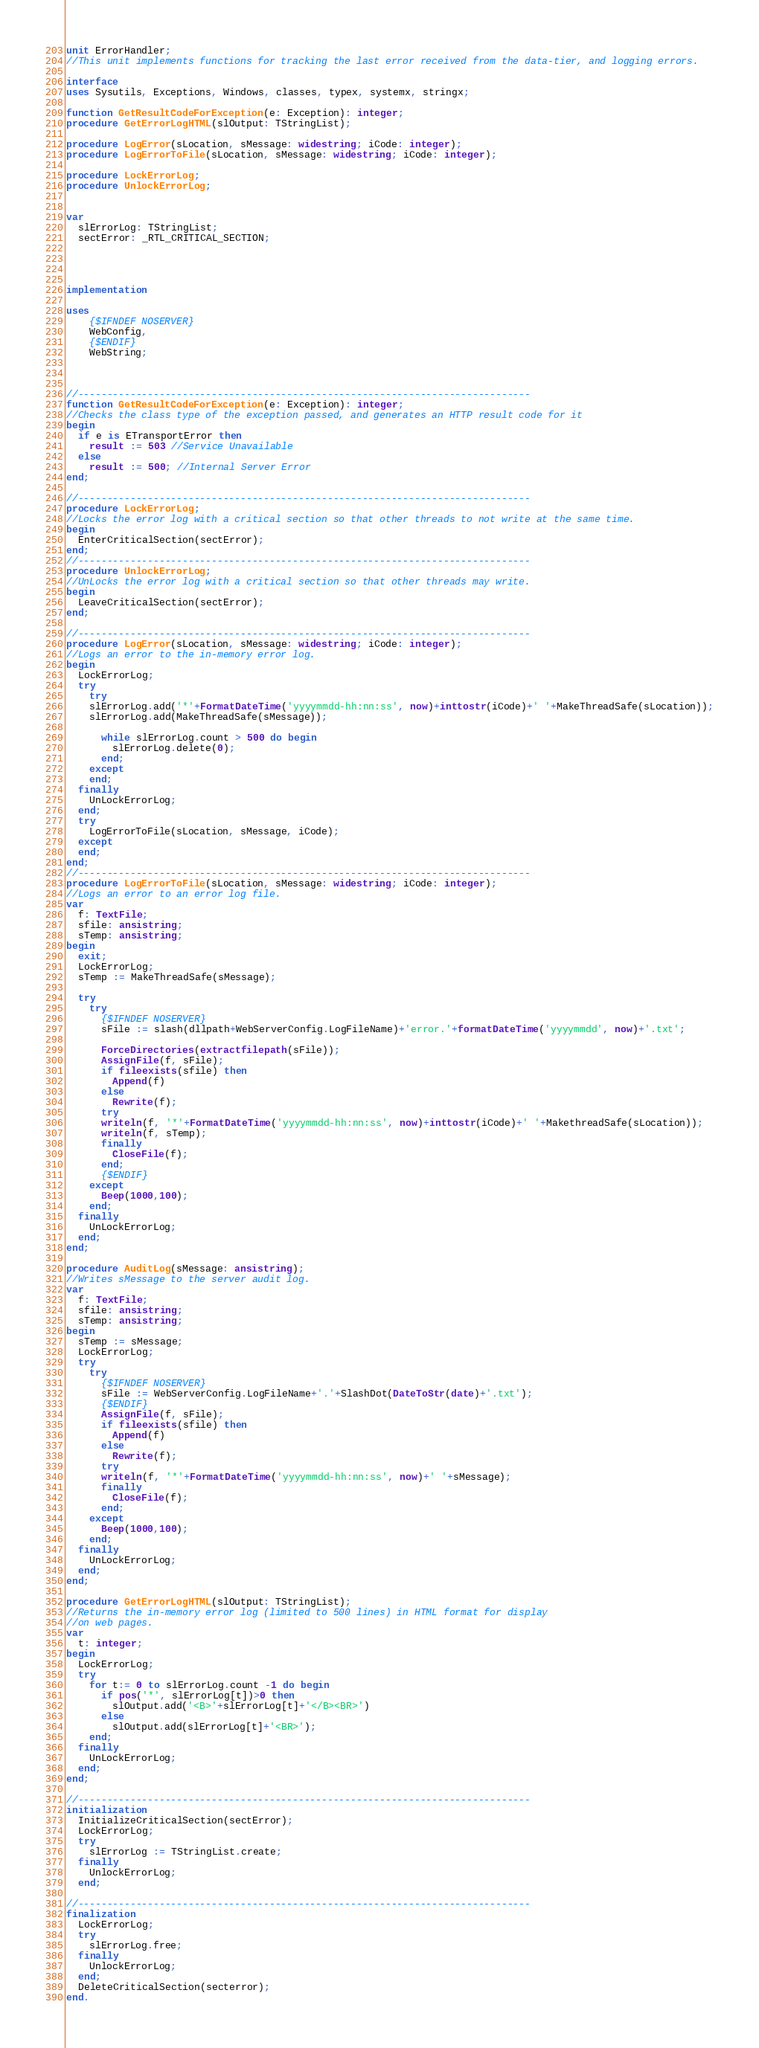Convert code to text. <code><loc_0><loc_0><loc_500><loc_500><_Pascal_>unit ErrorHandler;
//This unit implements functions for tracking the last error received from the data-tier, and logging errors.

interface
uses Sysutils, Exceptions, Windows, classes, typex, systemx, stringx;

function GetResultCodeForException(e: Exception): integer;
procedure GetErrorLogHTML(slOutput: TStringList);

procedure LogError(sLocation, sMessage: widestring; iCode: integer);
procedure LogErrorToFile(sLocation, sMessage: widestring; iCode: integer);

procedure LockErrorLog;
procedure UnlockErrorLog;


var
  slErrorLog: TStringList;
  sectError: _RTL_CRITICAL_SECTION;




implementation

uses
    {$IFNDEF NOSERVER}
    WebConfig,
    {$ENDIF}
    WebString;



//------------------------------------------------------------------------------
function GetResultCodeForException(e: Exception): integer;
//Checks the class type of the exception passed, and generates an HTTP result code for it
begin
  if e is ETransportError then
    result := 503 //Service Unavailable
  else
    result := 500; //Internal Server Error
end;

//------------------------------------------------------------------------------
procedure LockErrorLog;
//Locks the error log with a critical section so that other threads to not write at the same time.
begin
  EnterCriticalSection(sectError);
end;
//------------------------------------------------------------------------------
procedure UnlockErrorLog;
//UnLocks the error log with a critical section so that other threads may write.
begin
  LeaveCriticalSection(sectError);
end;

//------------------------------------------------------------------------------
procedure LogError(sLocation, sMessage: widestring; iCode: integer);
//Logs an error to the in-memory error log.
begin
  LockErrorLog;
  try
    try
    slErrorLog.add('*'+FormatDateTime('yyyymmdd-hh:nn:ss', now)+inttostr(iCode)+' '+MakeThreadSafe(sLocation));
    slErrorLog.add(MakeThreadSafe(sMessage));

      while slErrorLog.count > 500 do begin
        slErrorLog.delete(0);
      end;
    except
    end;
  finally
    UnLockErrorLog;
  end;
  try
    LogErrorToFile(sLocation, sMessage, iCode);
  except
  end;
end;
//------------------------------------------------------------------------------
procedure LogErrorToFile(sLocation, sMessage: widestring; iCode: integer);
//Logs an error to an error log file.
var
  f: TextFile;
  sfile: ansistring;
  sTemp: ansistring;
begin
  exit;
  LockErrorLog;
  sTemp := MakeThreadSafe(sMessage);

  try
    try
      {$IFNDEF NOSERVER}
      sFile := slash(dllpath+WebServerConfig.LogFileName)+'error.'+formatDateTime('yyyymmdd', now)+'.txt';

      ForceDirectories(extractfilepath(sFile));
      AssignFile(f, sFile);
      if fileexists(sfile) then
        Append(f)
      else
        Rewrite(f);
      try
      writeln(f, '*'+FormatDateTime('yyyymmdd-hh:nn:ss', now)+inttostr(iCode)+' '+MakethreadSafe(sLocation));
      writeln(f, sTemp);
      finally
        CloseFile(f);
      end;
      {$ENDIF}
    except
      Beep(1000,100);
    end;
  finally
    UnLockErrorLog;
  end;
end;

procedure AuditLog(sMessage: ansistring);
//Writes sMessage to the server audit log.
var
  f: TextFile;
  sfile: ansistring;
  sTemp: ansistring;
begin
  sTemp := sMessage;
  LockErrorLog;
  try
    try
      {$IFNDEF NOSERVER}
      sFile := WebServerConfig.LogFileName+'.'+SlashDot(DateToStr(date)+'.txt');
      {$ENDIF}
      AssignFile(f, sFile);
      if fileexists(sfile) then
        Append(f)
      else
        Rewrite(f);
      try
      writeln(f, '*'+FormatDateTime('yyyymmdd-hh:nn:ss', now)+' '+sMessage);
      finally
        CloseFile(f);
      end;
    except
      Beep(1000,100);
    end;
  finally
    UnLockErrorLog;
  end;
end;

procedure GetErrorLogHTML(slOutput: TStringList);
//Returns the in-memory error log (limited to 500 lines) in HTML format for display
//on web pages.
var
  t: integer;
begin
  LockErrorLog;
  try
    for t:= 0 to slErrorLog.count -1 do begin
      if pos('*', slErrorLog[t])>0 then
        slOutput.add('<B>'+slErrorLog[t]+'</B><BR>')
      else
        slOutput.add(slErrorLog[t]+'<BR>');
    end;
  finally
    UnLockErrorLog;
  end;
end;

//------------------------------------------------------------------------------
initialization
  InitializeCriticalSection(sectError);
  LockErrorLog;
  try
    slErrorLog := TStringList.create;
  finally
    UnlockErrorLog;
  end;

//------------------------------------------------------------------------------
finalization
  LockErrorLog;
  try
    slErrorLog.free;
  finally
    UnlockErrorLog;
  end;
  DeleteCriticalSection(secterror);
end.
</code> 